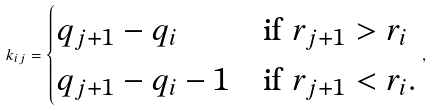<formula> <loc_0><loc_0><loc_500><loc_500>k _ { i j } = \begin{cases} q _ { j + 1 } - q _ { i } & \text {if } r _ { j + 1 } > r _ { i } \\ q _ { j + 1 } - q _ { i } - 1 & \text {if } r _ { j + 1 } < r _ { i } . \end{cases} ,</formula> 